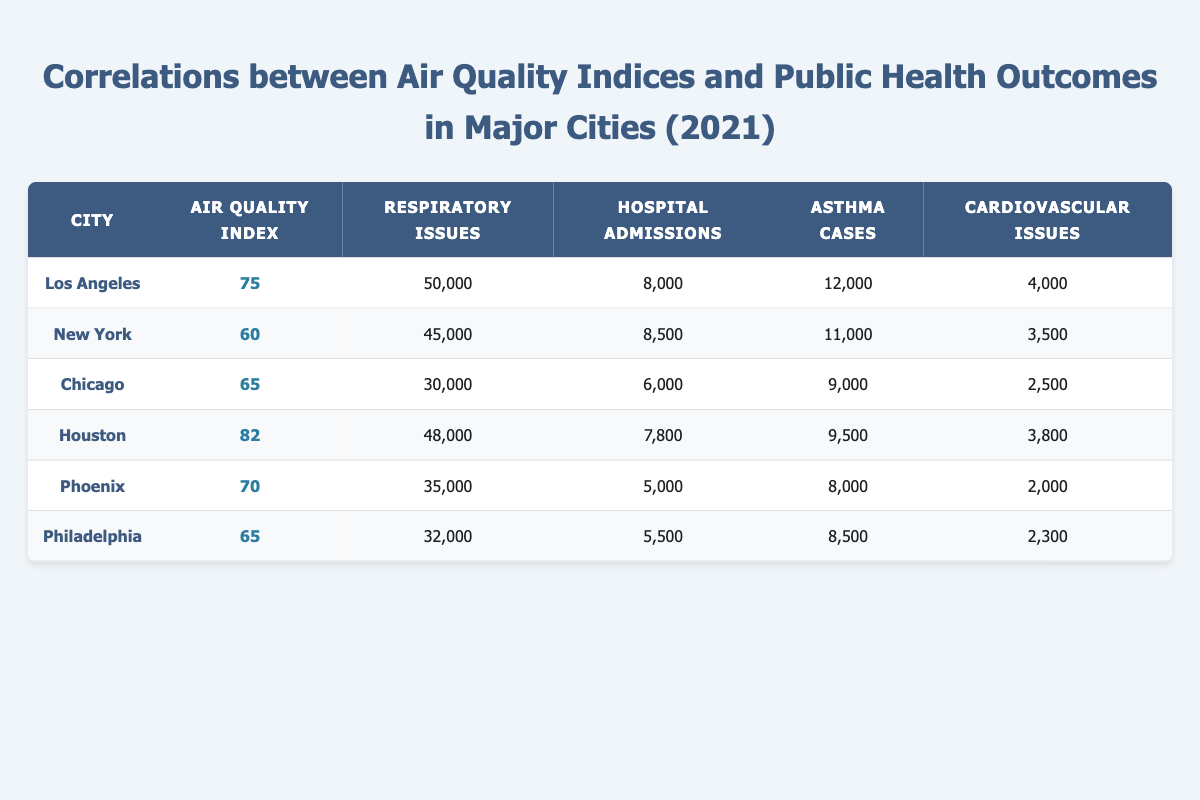What is the air quality index of Houston? Houston's row in the table shows an air quality index of 82.
Answer: 82 Which city has the highest number of respiratory issues? By comparing the respiratory issues across all cities listed, Los Angeles has the highest number at 50,000.
Answer: Los Angeles What is the average number of hospital admissions across these cities? To calculate the average, add the hospital admissions for all cities: (8000 + 8500 + 6000 + 7800 + 5000 + 5500) = 43,800. Then divide by the number of cities (6): 43,800 / 6 = 7,300.
Answer: 7,300 Do both New York and Chicago have air quality indices below 70? New York has an air quality index of 60 (below 70), and Chicago has an air quality index of 65 (also below 70). Therefore, the statement is true for both cities.
Answer: Yes What is the difference in asthma cases between Los Angeles and Philadelphia? Los Angeles has 12,000 asthma cases, while Philadelphia has 8,500. The difference is 12,000 - 8,500 = 3,500.
Answer: 3,500 Are there any cities with over 40,000 respiratory issues? Both Los Angeles (50,000) and Houston (48,000) have over 40,000 respiratory issues. Thus, the answer is yes, there are cities that meet this condition.
Answer: Yes What is the total number of cardiovascular issues reported in all six cities? To find the total, sum up the cardiovascular issues: (4000 + 3500 + 2500 + 3800 + 2000 + 2300) = 18,100.
Answer: 18,100 Which city has the lowest air quality index? By examining the air quality indices for all cities, New York has the lowest at 60.
Answer: New York Is there a city with both the highest air quality index and the lowest number of hospital admissions? Houston has the highest air quality index (82) but does not have the lowest number of hospital admissions (which belongs to Phoenix with 5,000). Thus, the statement is false.
Answer: No 